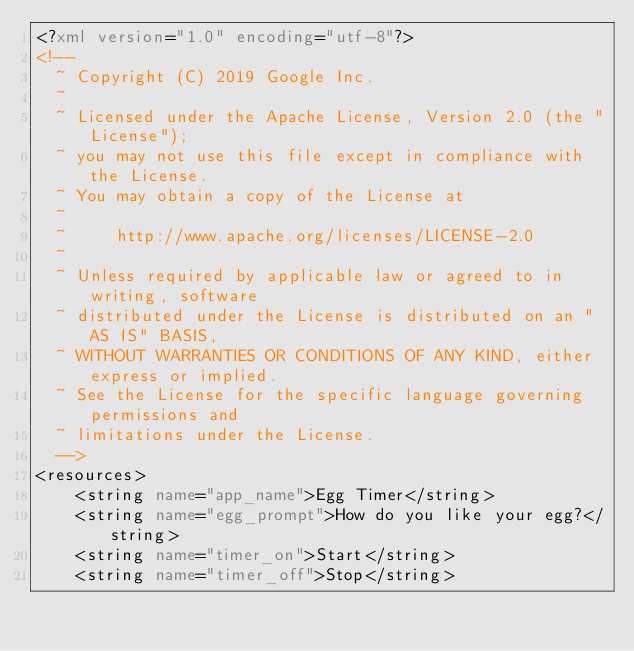Convert code to text. <code><loc_0><loc_0><loc_500><loc_500><_XML_><?xml version="1.0" encoding="utf-8"?>
<!--
  ~ Copyright (C) 2019 Google Inc.
  ~
  ~ Licensed under the Apache License, Version 2.0 (the "License");
  ~ you may not use this file except in compliance with the License.
  ~ You may obtain a copy of the License at
  ~
  ~     http://www.apache.org/licenses/LICENSE-2.0
  ~
  ~ Unless required by applicable law or agreed to in writing, software
  ~ distributed under the License is distributed on an "AS IS" BASIS,
  ~ WITHOUT WARRANTIES OR CONDITIONS OF ANY KIND, either express or implied.
  ~ See the License for the specific language governing permissions and
  ~ limitations under the License.
  -->
<resources>
    <string name="app_name">Egg Timer</string>
    <string name="egg_prompt">How do you like your egg?</string>
    <string name="timer_on">Start</string>
    <string name="timer_off">Stop</string></code> 